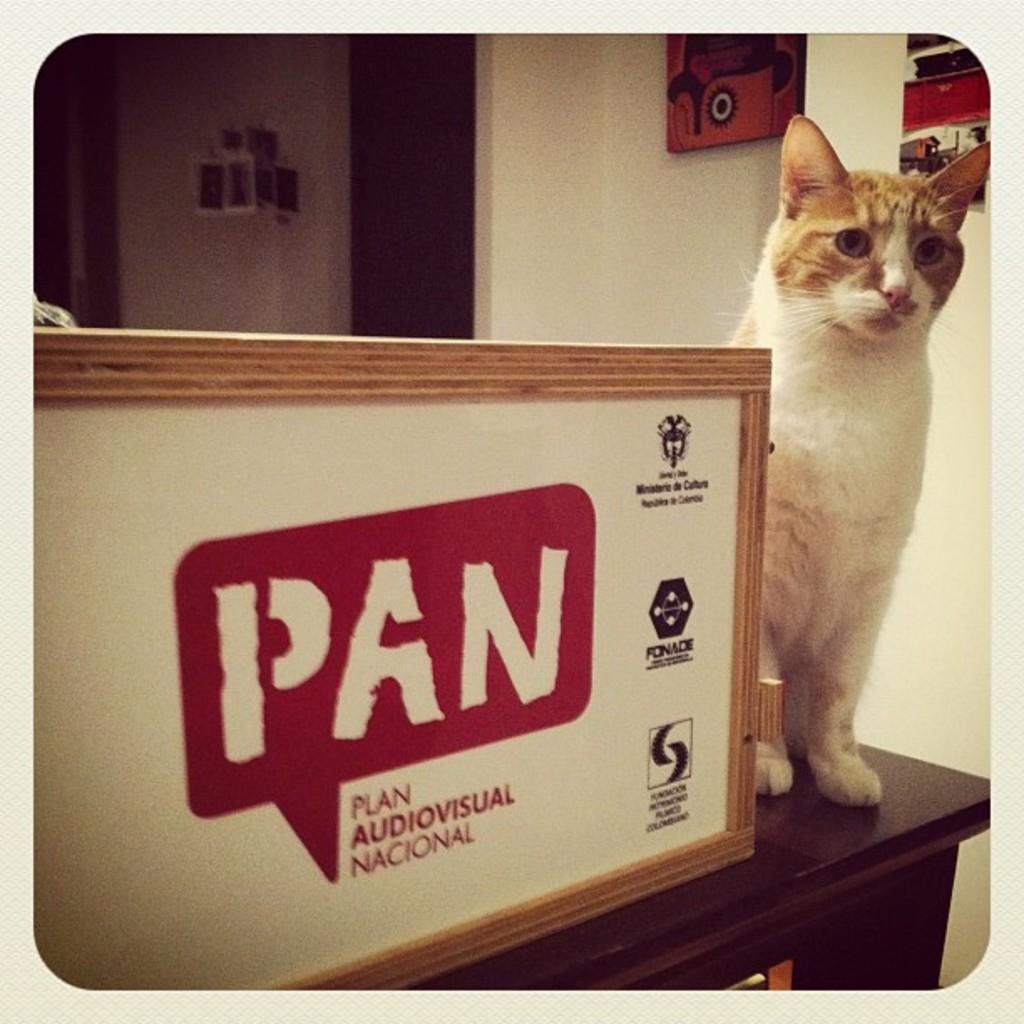What is the main object in the foreground of the image? There is a wooden box-like object in the foreground of the image. What type of animal can be seen on a table in the foreground of the image? A cat is present on a table in the foreground of the image. What can be seen on the wall in the background of the image? There are frames on the wall in the background of the image. What else is visible in the background of the image? There are additional objects visible in the background of the image. Who is the owner of the cat in the image? There is no information about the cat's owner in the image. What type of amusement can be seen in the image? There is no amusement present in the image; it features a wooden box-like object, a cat on a table, frames on the wall, and additional objects in the background. 